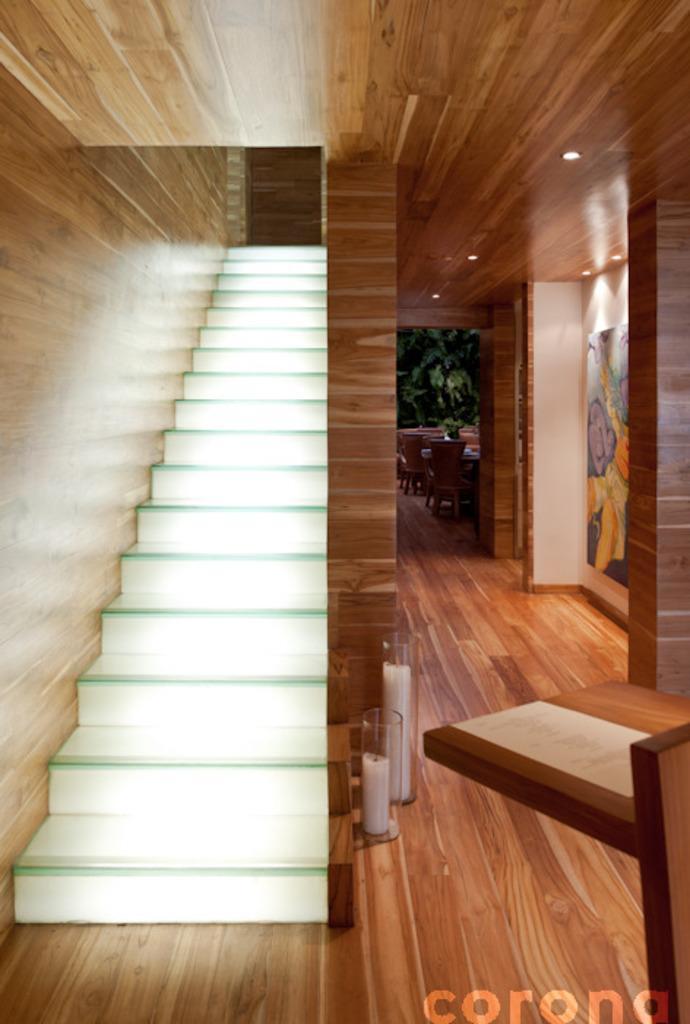How would you summarize this image in a sentence or two? In this image I can see stairs, candles, pillars and other objects on the floor. Here I can see a watermark. 